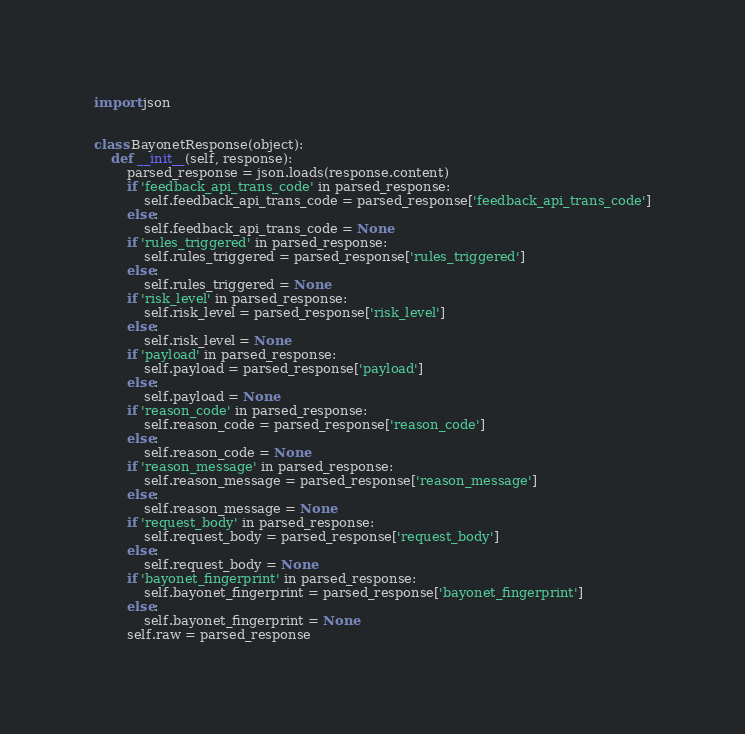<code> <loc_0><loc_0><loc_500><loc_500><_Python_>import json


class BayonetResponse(object):
    def __init__(self, response):
        parsed_response = json.loads(response.content)
        if 'feedback_api_trans_code' in parsed_response:
            self.feedback_api_trans_code = parsed_response['feedback_api_trans_code']
        else:
            self.feedback_api_trans_code = None
        if 'rules_triggered' in parsed_response:
            self.rules_triggered = parsed_response['rules_triggered']
        else:
            self.rules_triggered = None
        if 'risk_level' in parsed_response:
            self.risk_level = parsed_response['risk_level']
        else:
            self.risk_level = None
        if 'payload' in parsed_response:
            self.payload = parsed_response['payload']
        else:
            self.payload = None
        if 'reason_code' in parsed_response:
            self.reason_code = parsed_response['reason_code']
        else:
            self.reason_code = None
        if 'reason_message' in parsed_response:
            self.reason_message = parsed_response['reason_message']
        else:
            self.reason_message = None
        if 'request_body' in parsed_response:
            self.request_body = parsed_response['request_body']
        else:
            self.request_body = None
        if 'bayonet_fingerprint' in parsed_response:
            self.bayonet_fingerprint = parsed_response['bayonet_fingerprint']
        else:
            self.bayonet_fingerprint = None
        self.raw = parsed_response
</code> 